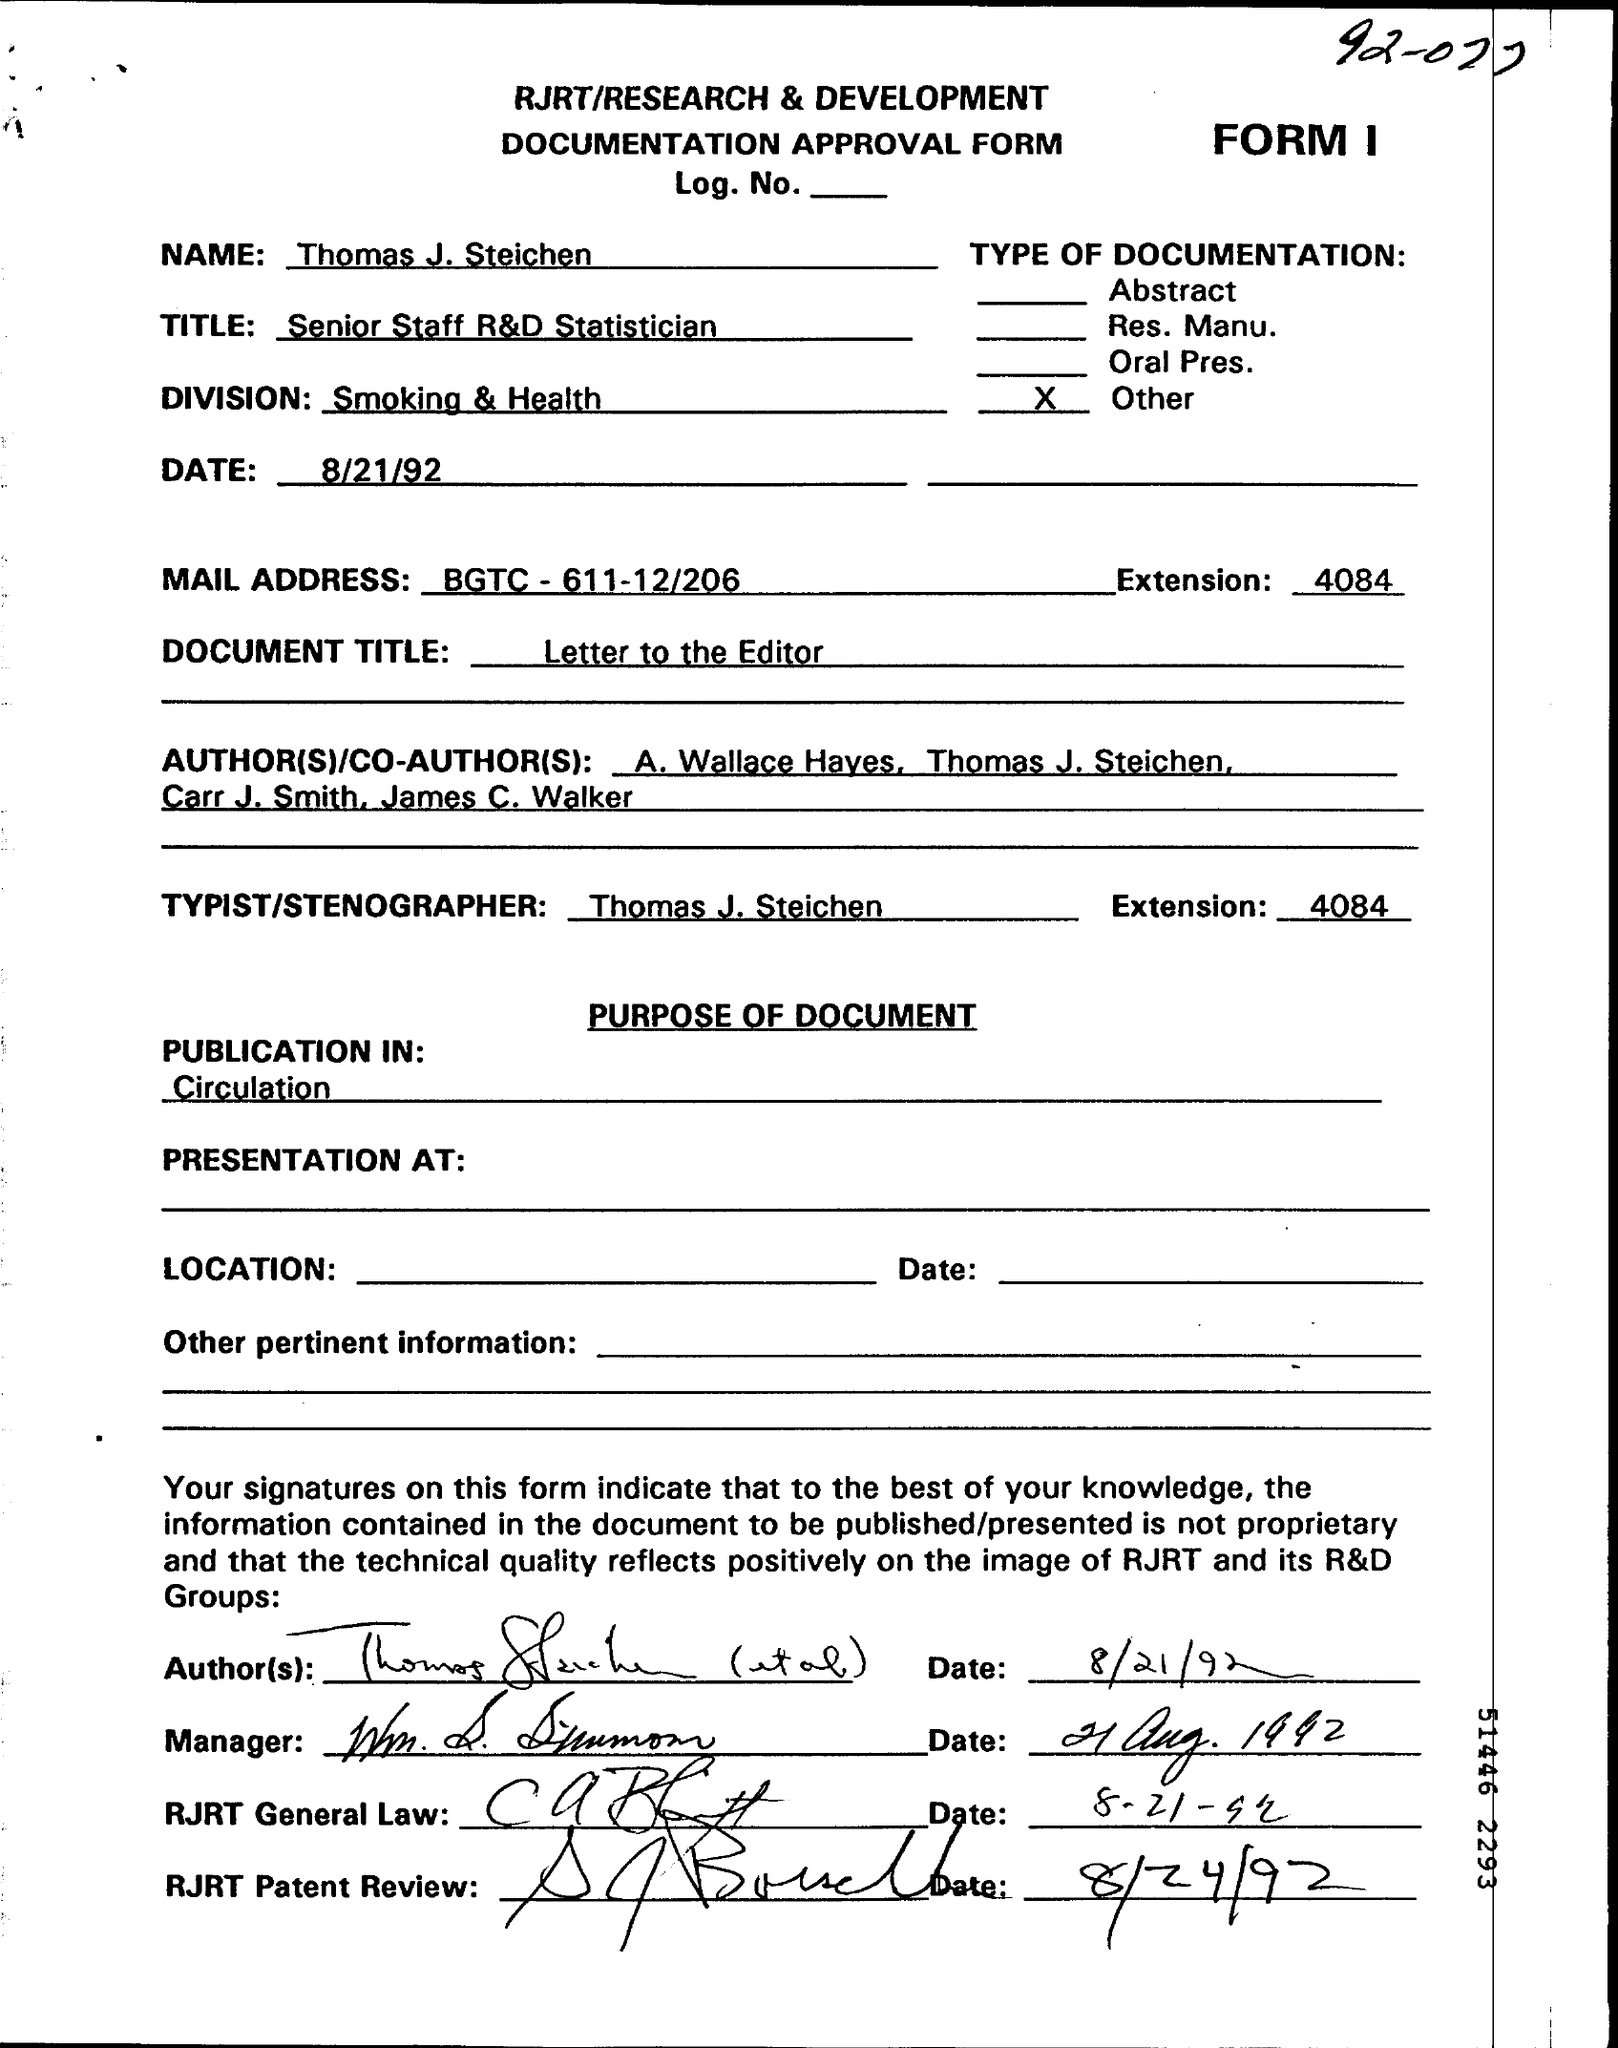Specify some key components in this picture. The name is Thomas J. Steichen. Thomas J. Steichen is the typist/stenographer. What is the extension?" is a question that can be rephrased as "Please inform me of the extension." or "Can you tell me the extension? What is the document title? Letter to the editor... The Division of Smoking and Health is a federal agency that focuses on research, education, and policy related to the health consequences of smoking and exposure to secondhand smoke. 